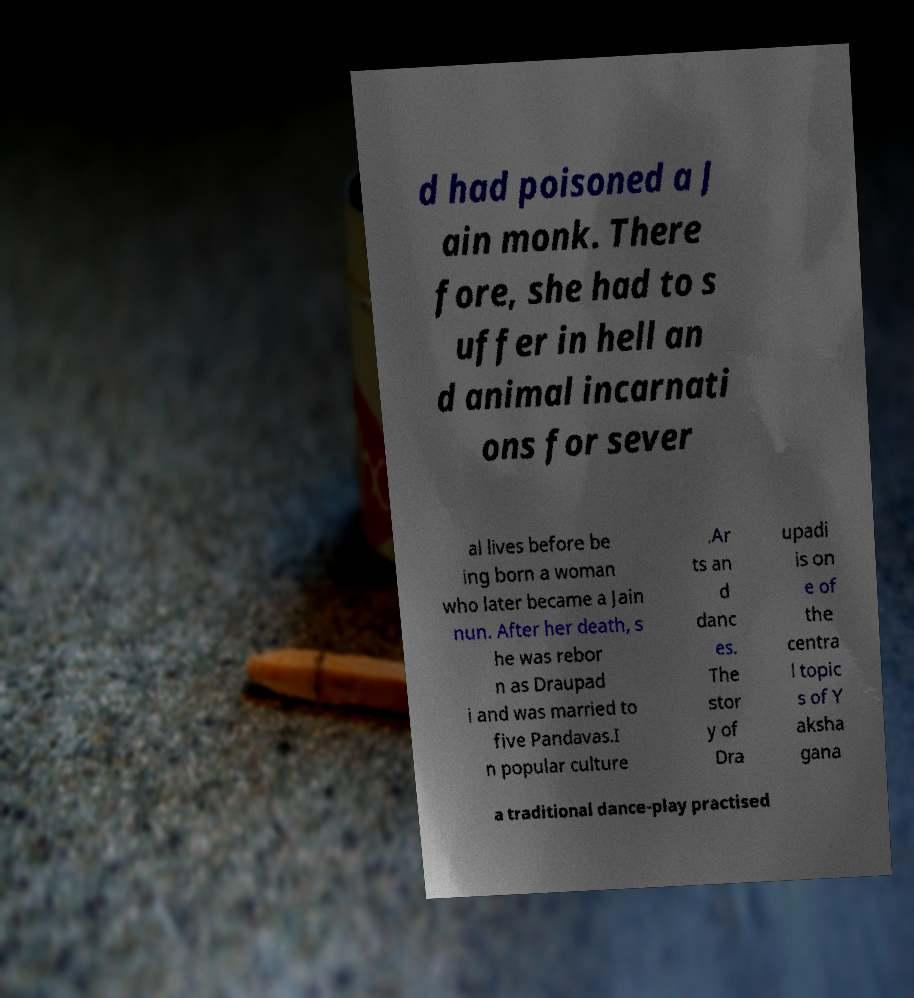Could you assist in decoding the text presented in this image and type it out clearly? d had poisoned a J ain monk. There fore, she had to s uffer in hell an d animal incarnati ons for sever al lives before be ing born a woman who later became a Jain nun. After her death, s he was rebor n as Draupad i and was married to five Pandavas.I n popular culture .Ar ts an d danc es. The stor y of Dra upadi is on e of the centra l topic s of Y aksha gana a traditional dance-play practised 